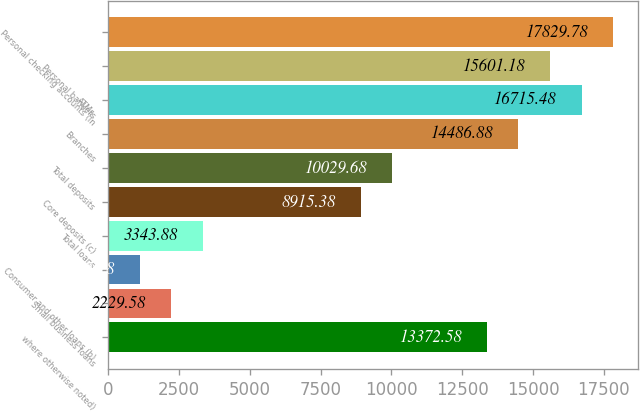Convert chart. <chart><loc_0><loc_0><loc_500><loc_500><bar_chart><fcel>where otherwise noted)<fcel>Small business loans<fcel>Consumer and other loans (b)<fcel>Total loans<fcel>Core deposits (c)<fcel>Total deposits<fcel>Branches<fcel>ATMs<fcel>Personal bankers<fcel>Personal checking accounts (in<nl><fcel>13372.6<fcel>2229.58<fcel>1115.28<fcel>3343.88<fcel>8915.38<fcel>10029.7<fcel>14486.9<fcel>16715.5<fcel>15601.2<fcel>17829.8<nl></chart> 